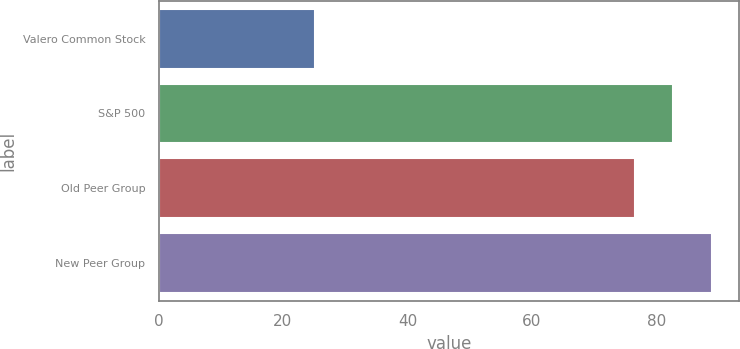<chart> <loc_0><loc_0><loc_500><loc_500><bar_chart><fcel>Valero Common Stock<fcel>S&P 500<fcel>Old Peer Group<fcel>New Peer Group<nl><fcel>25.09<fcel>82.72<fcel>76.54<fcel>88.9<nl></chart> 